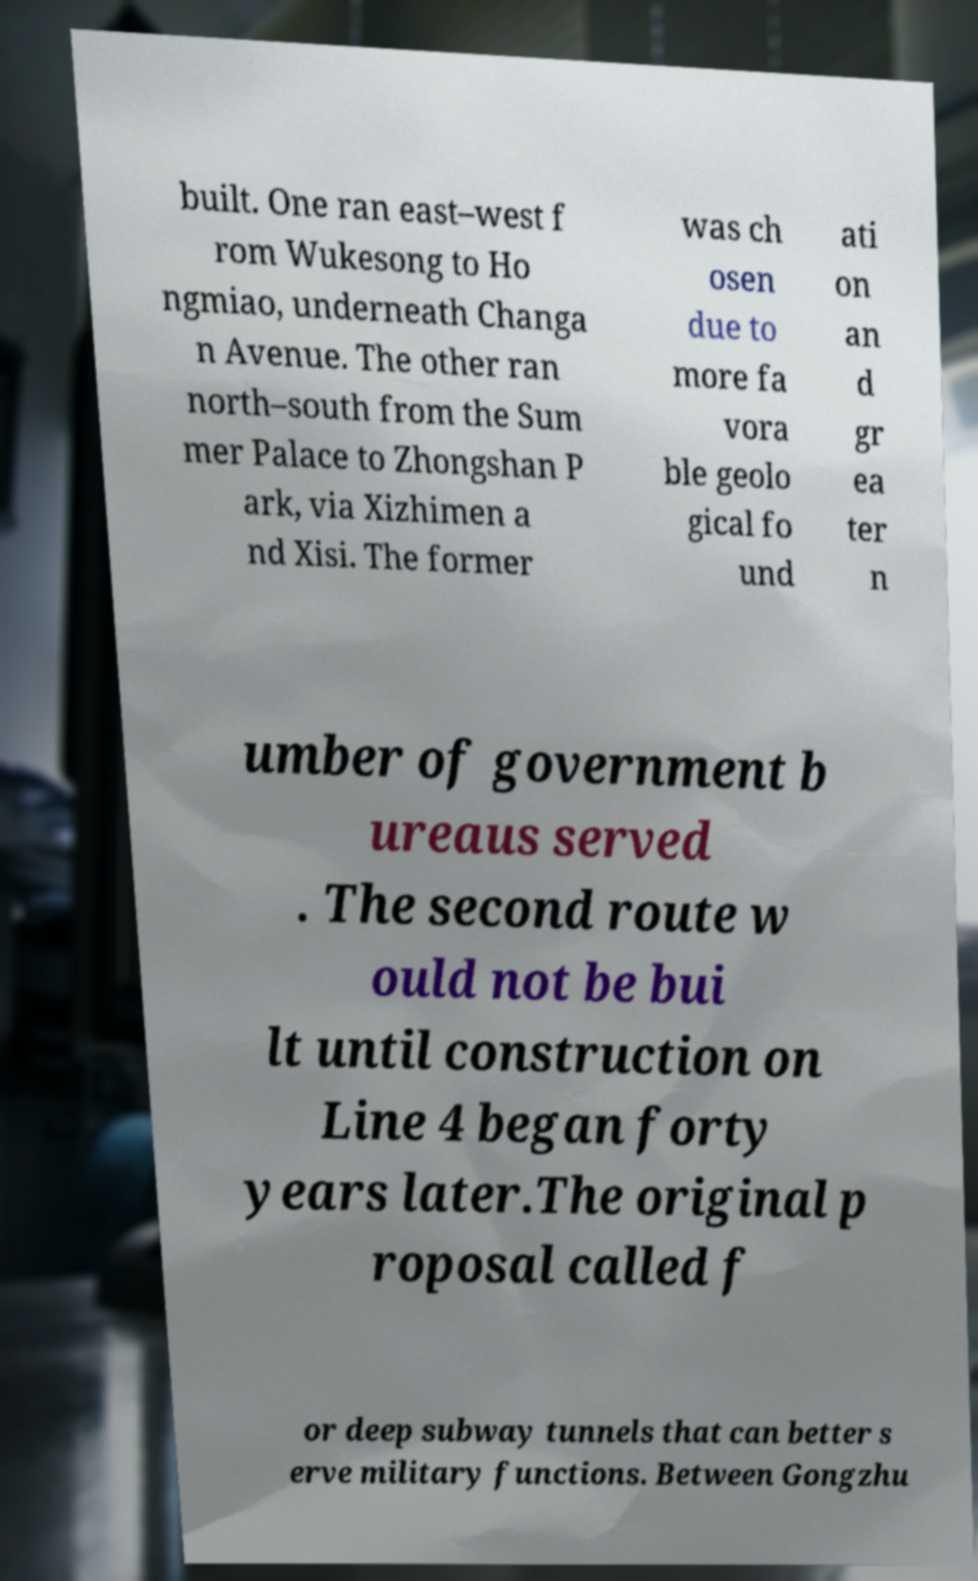I need the written content from this picture converted into text. Can you do that? built. One ran east–west f rom Wukesong to Ho ngmiao, underneath Changa n Avenue. The other ran north–south from the Sum mer Palace to Zhongshan P ark, via Xizhimen a nd Xisi. The former was ch osen due to more fa vora ble geolo gical fo und ati on an d gr ea ter n umber of government b ureaus served . The second route w ould not be bui lt until construction on Line 4 began forty years later.The original p roposal called f or deep subway tunnels that can better s erve military functions. Between Gongzhu 